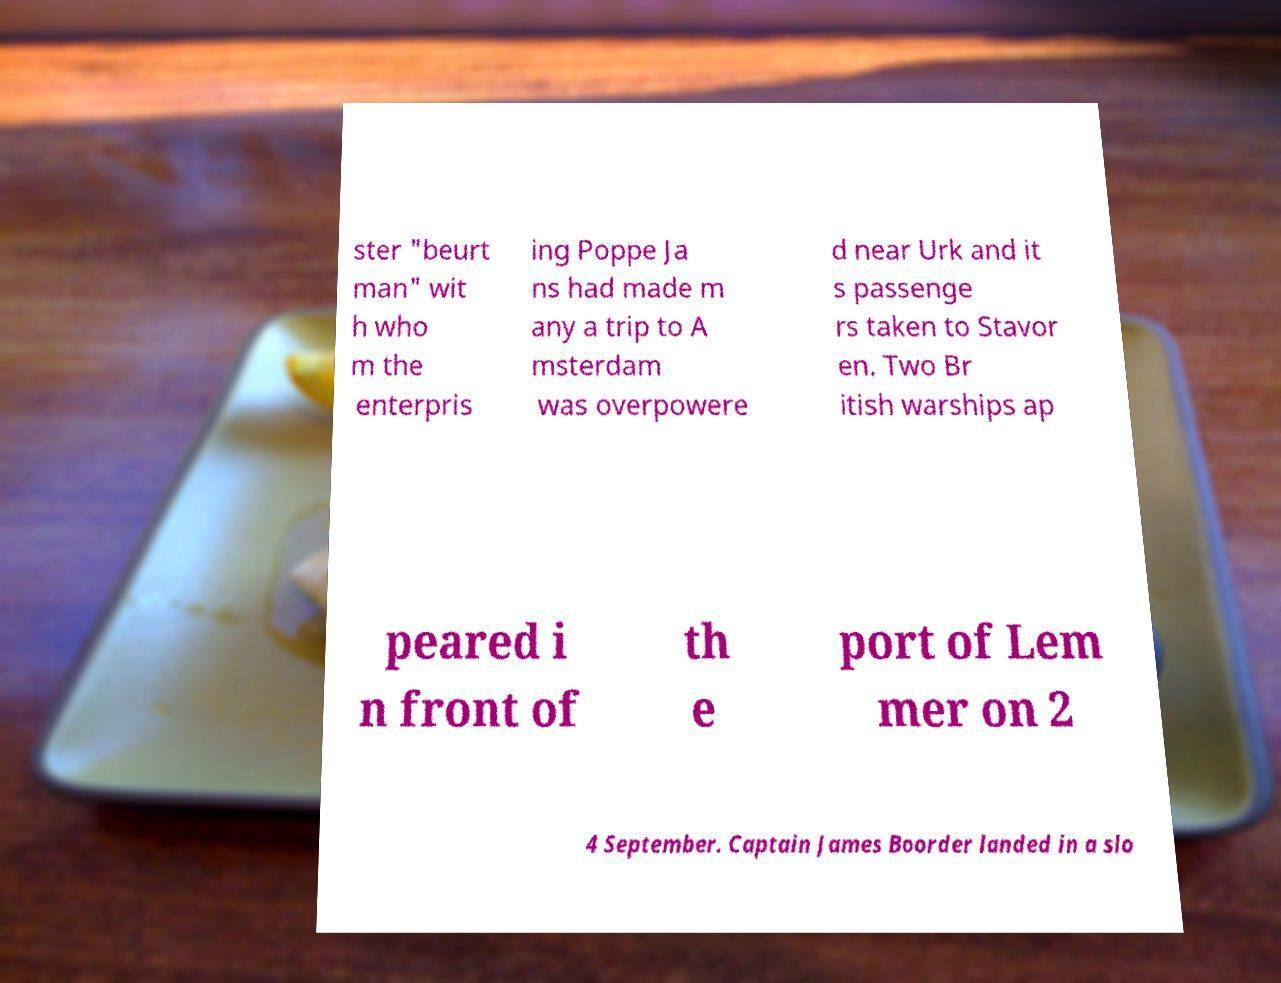I need the written content from this picture converted into text. Can you do that? ster "beurt man" wit h who m the enterpris ing Poppe Ja ns had made m any a trip to A msterdam was overpowere d near Urk and it s passenge rs taken to Stavor en. Two Br itish warships ap peared i n front of th e port of Lem mer on 2 4 September. Captain James Boorder landed in a slo 